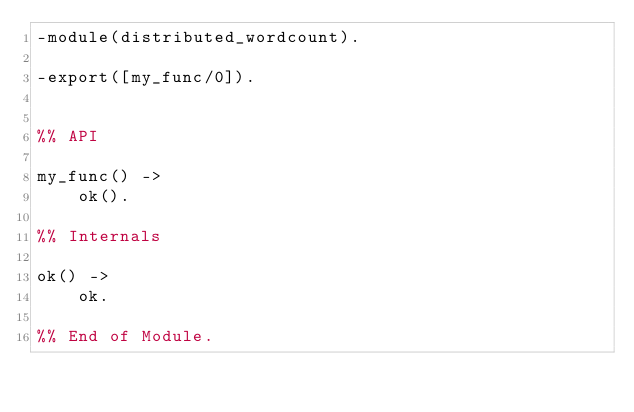Convert code to text. <code><loc_0><loc_0><loc_500><loc_500><_Erlang_>-module(distributed_wordcount).

-export([my_func/0]).


%% API

my_func() ->
    ok().

%% Internals

ok() ->
    ok.

%% End of Module.
</code> 